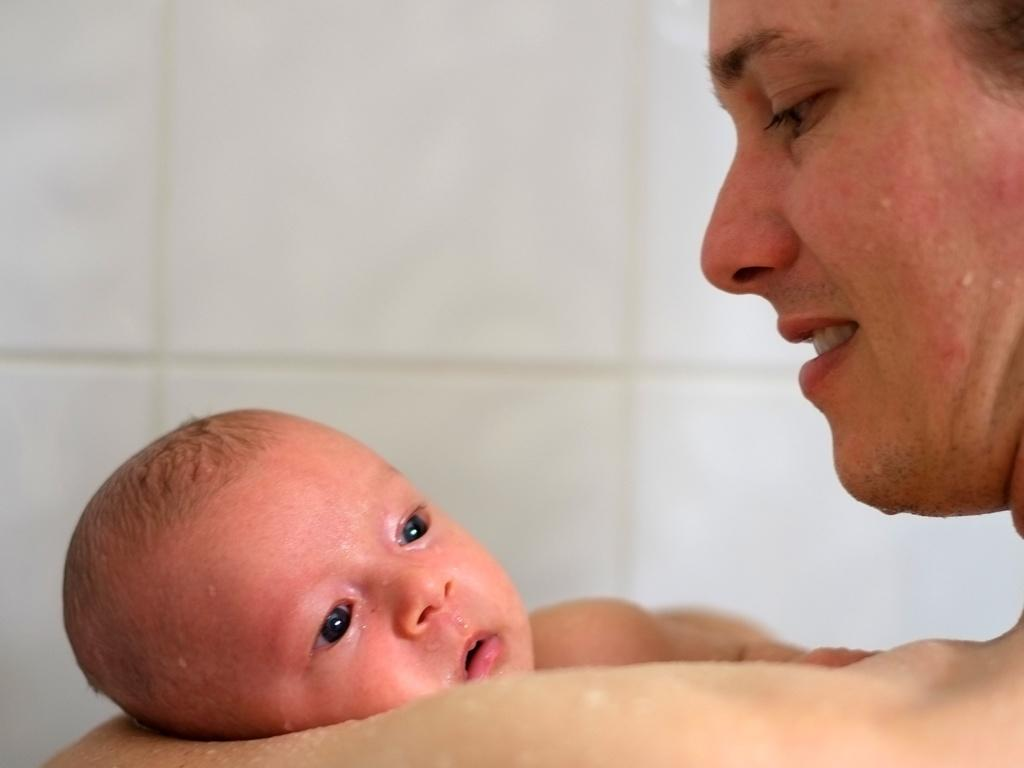What is the person in the image doing? The person is holding a baby in the image. Can you describe anything near the person and baby? A water droplet is visible near the person and baby. What can be seen in the background of the image? There is a wall with white tiles in the background of the image. What type of horse can be seen in the image? There is no horse present in the image. What unit of measurement is used to determine the size of the water droplet? The size of the water droplet cannot be determined from the image, and no unit of measurement is mentioned. 